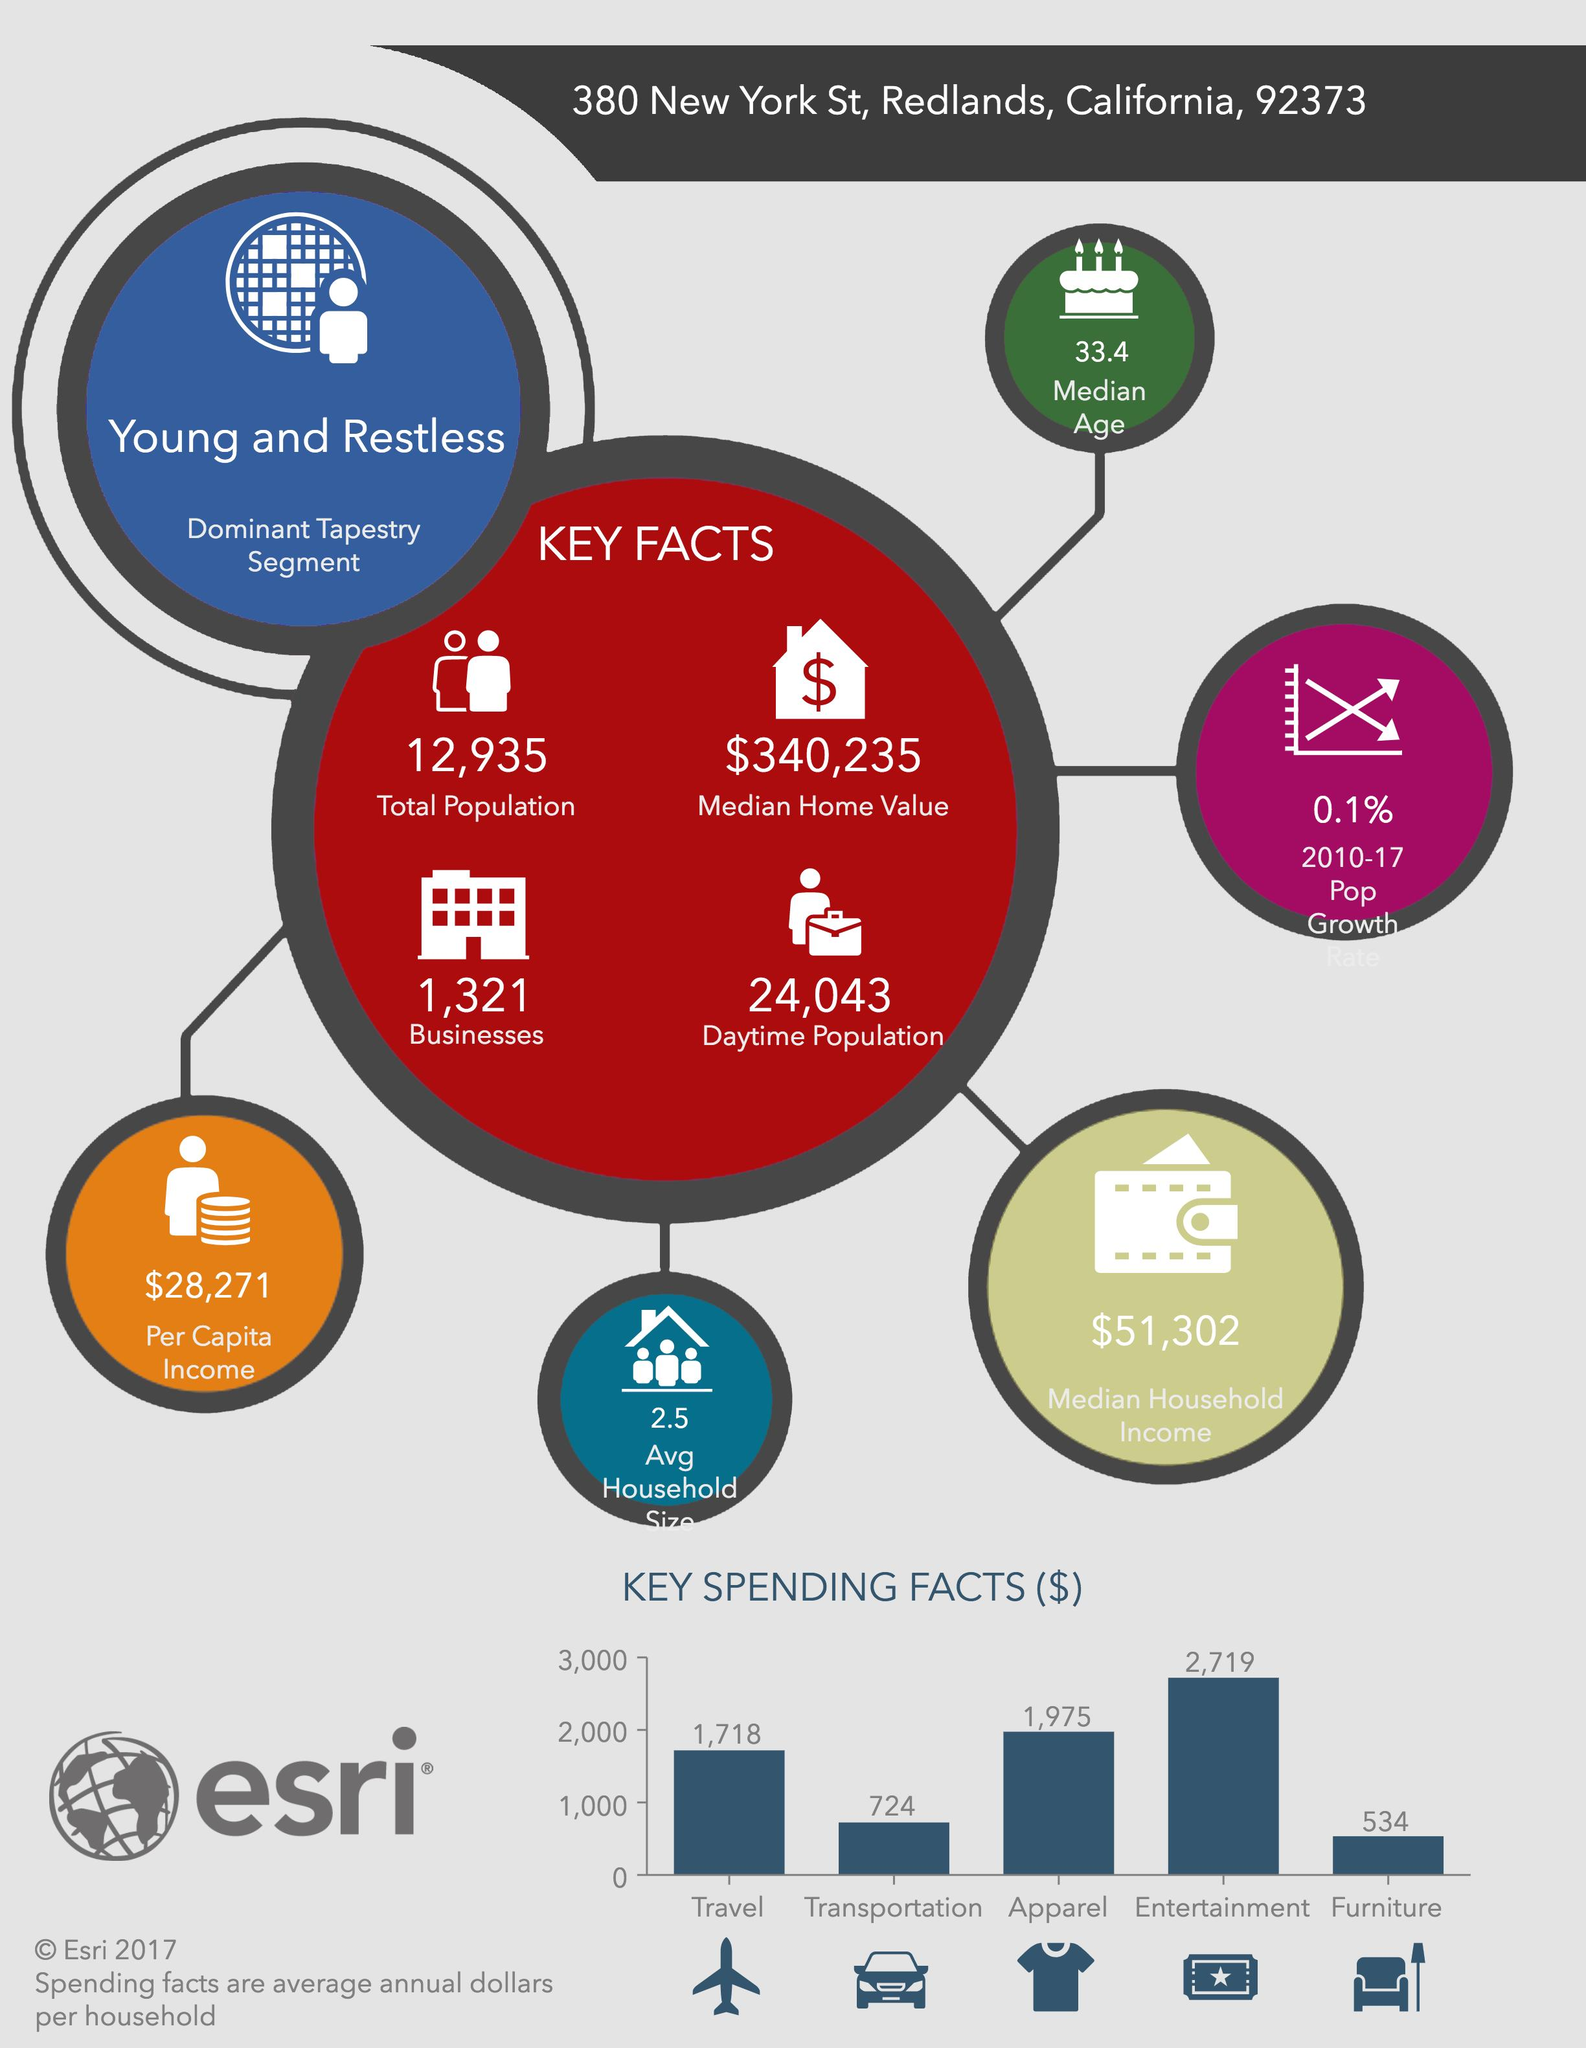Outline some significant characteristics in this image. The City of New York spent a total of 2,442 dollars on both travel and transportation expenses. The per capita income of New York is $28,271. New York spends the second least amount of cash on transportation among all items. For which categories does New York spend more than $1000? Travel, apparel, and entertainment. The daytime crowdedness in New York is approximately 24,043. 